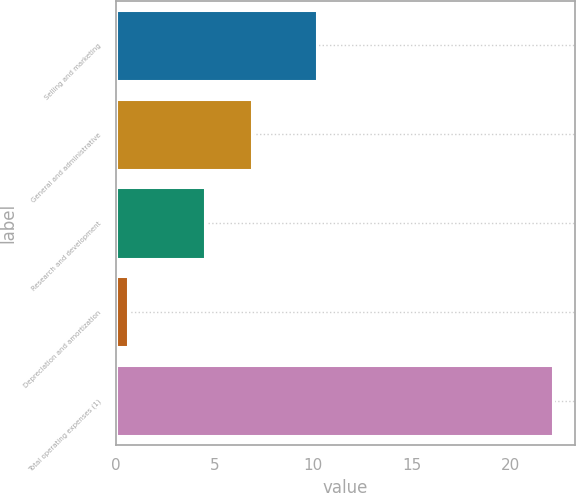Convert chart to OTSL. <chart><loc_0><loc_0><loc_500><loc_500><bar_chart><fcel>Selling and marketing<fcel>General and administrative<fcel>Research and development<fcel>Depreciation and amortization<fcel>Total operating expenses (1)<nl><fcel>10.2<fcel>6.9<fcel>4.5<fcel>0.6<fcel>22.2<nl></chart> 